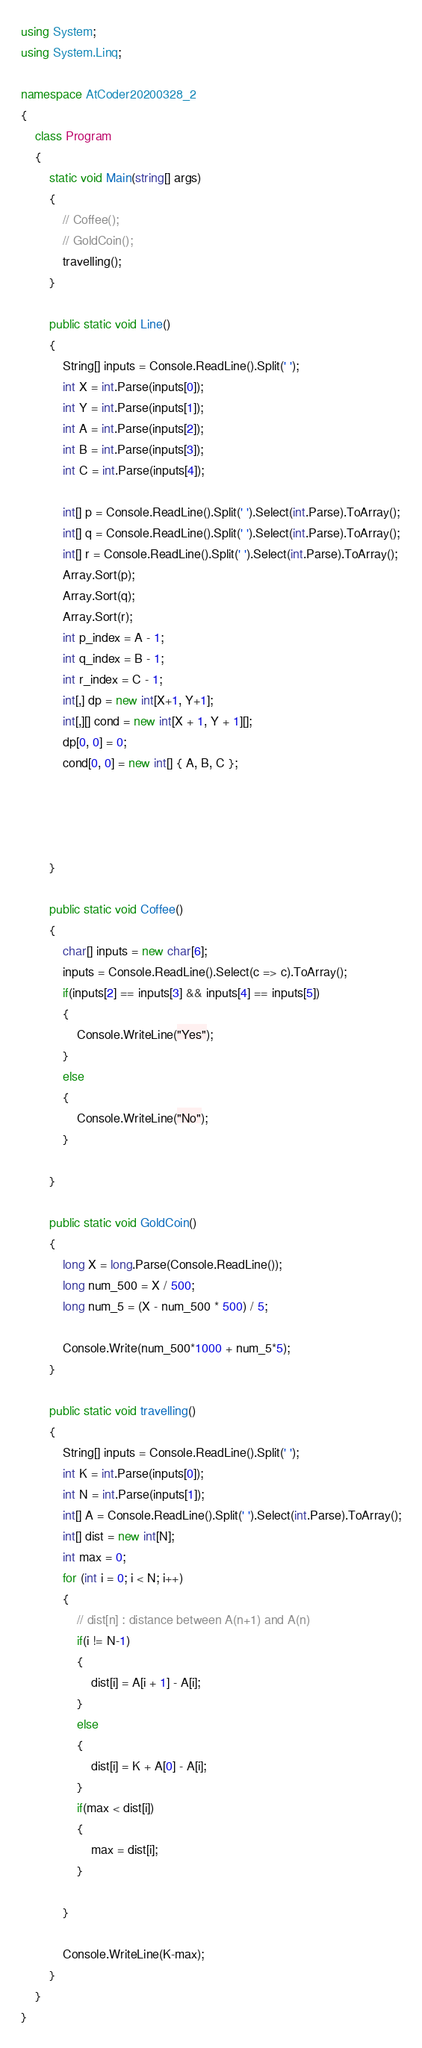<code> <loc_0><loc_0><loc_500><loc_500><_C#_>using System;
using System.Linq;

namespace AtCoder20200328_2
{
    class Program
    {
        static void Main(string[] args)
        {
            // Coffee();
            // GoldCoin();
            travelling();
        }

        public static void Line()
        {
            String[] inputs = Console.ReadLine().Split(' ');
            int X = int.Parse(inputs[0]);
            int Y = int.Parse(inputs[1]);
            int A = int.Parse(inputs[2]);
            int B = int.Parse(inputs[3]);
            int C = int.Parse(inputs[4]);

            int[] p = Console.ReadLine().Split(' ').Select(int.Parse).ToArray();
            int[] q = Console.ReadLine().Split(' ').Select(int.Parse).ToArray();
            int[] r = Console.ReadLine().Split(' ').Select(int.Parse).ToArray();
            Array.Sort(p);
            Array.Sort(q);
            Array.Sort(r);
            int p_index = A - 1;
            int q_index = B - 1;
            int r_index = C - 1;
            int[,] dp = new int[X+1, Y+1];
            int[,][] cond = new int[X + 1, Y + 1][];
            dp[0, 0] = 0;
            cond[0, 0] = new int[] { A, B, C };


            

        }

        public static void Coffee()
        {
            char[] inputs = new char[6];
            inputs = Console.ReadLine().Select(c => c).ToArray();
            if(inputs[2] == inputs[3] && inputs[4] == inputs[5])
            {
                Console.WriteLine("Yes");
            }
            else
            {
                Console.WriteLine("No");
            }

        }

        public static void GoldCoin()
        {
            long X = long.Parse(Console.ReadLine());
            long num_500 = X / 500;
            long num_5 = (X - num_500 * 500) / 5;

            Console.Write(num_500*1000 + num_5*5);
        }

        public static void travelling()
        {
            String[] inputs = Console.ReadLine().Split(' ');
            int K = int.Parse(inputs[0]);
            int N = int.Parse(inputs[1]);
            int[] A = Console.ReadLine().Split(' ').Select(int.Parse).ToArray();
            int[] dist = new int[N];
            int max = 0;
            for (int i = 0; i < N; i++)
            {
                // dist[n] : distance between A(n+1) and A(n)
                if(i != N-1)
                { 
                    dist[i] = A[i + 1] - A[i];
                }
                else
                {
                    dist[i] = K + A[0] - A[i];
                }
                if(max < dist[i])
                {
                    max = dist[i];
                }

            }

            Console.WriteLine(K-max);
        }
    }
}
</code> 